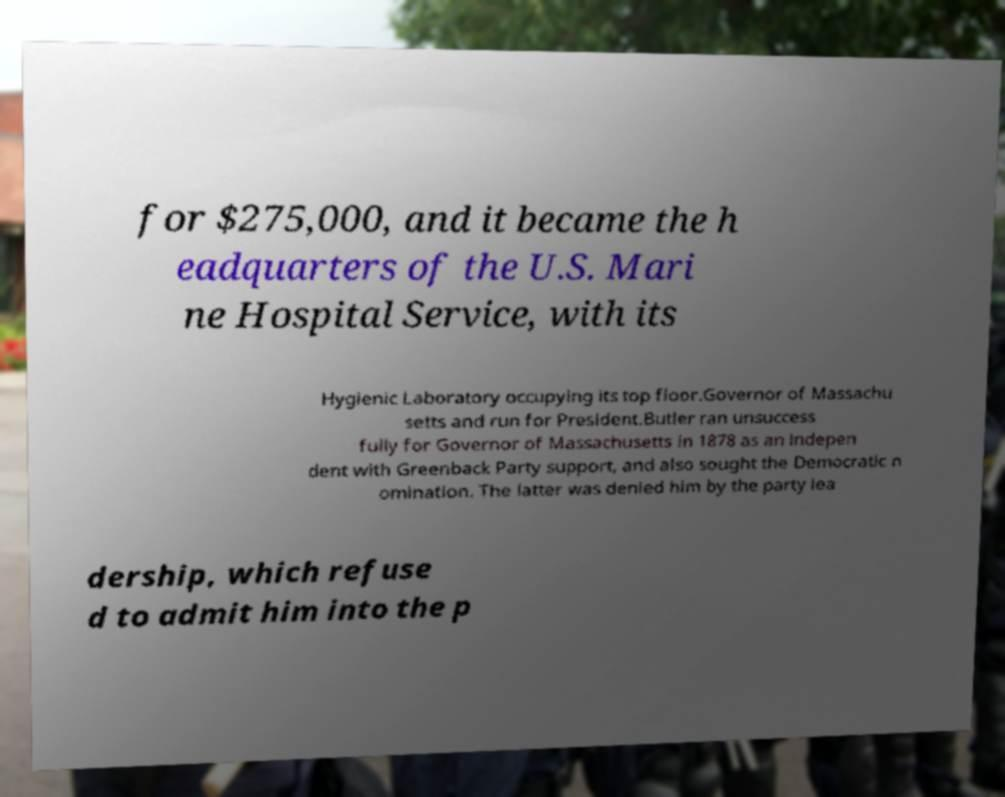For documentation purposes, I need the text within this image transcribed. Could you provide that? for $275,000, and it became the h eadquarters of the U.S. Mari ne Hospital Service, with its Hygienic Laboratory occupying its top floor.Governor of Massachu setts and run for President.Butler ran unsuccess fully for Governor of Massachusetts in 1878 as an indepen dent with Greenback Party support, and also sought the Democratic n omination. The latter was denied him by the party lea dership, which refuse d to admit him into the p 